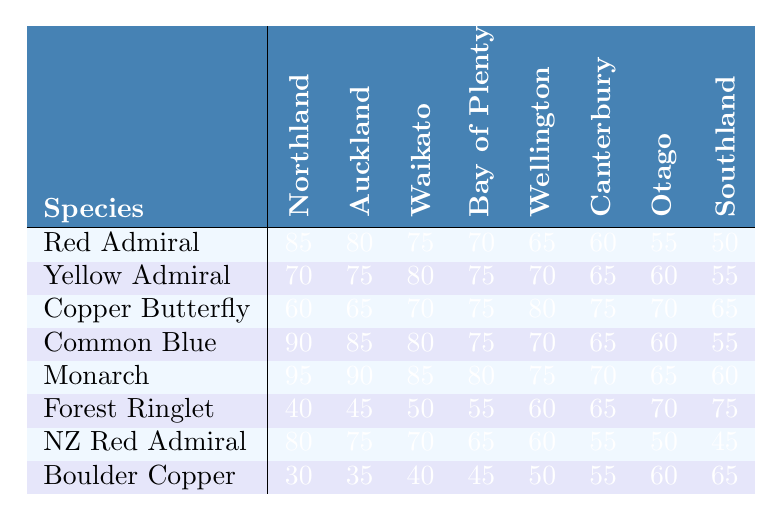What is the highest distribution value for the Monarch species? The table shows the distribution values for the Monarch species across the regions. The highest value listed is 95, corresponding to Northland.
Answer: 95 Which butterfly species has the lowest distribution in Southland? Looking at the Southland column, the lowest value is 45, which belongs to the New Zealand Red Admiral species.
Answer: New Zealand Red Admiral What is the average distribution for the Yellow Admiral species across all regions? To find the average for the Yellow Admiral, sum the distribution values (70 + 75 + 80 + 75 + 70 + 65 + 60 + 55) = 570, then divide by the number of regions (8): 570 / 8 = 71.25.
Answer: 71.25 Is the distribution of the Forest Ringlet species increasing or decreasing as one moves from Northland to Southland? Checking the distribution values for the Forest Ringlet from Northland to Southland (40, 45, 50, 55, 60, 65, 70, 75), we see that each subsequent value increases.
Answer: Increasing What is the difference in distribution between the Common Blue and Copper Butterfly in Wellington? The distribution for Common Blue in Wellington is 70 and for Copper Butterfly, it is 80. The difference is 80 - 70 = 10.
Answer: 10 Which species shows the most consistent distribution across all regions? The Copper Butterfly's distribution values (60, 65, 70, 75, 80, 75, 70, 65) vary by a maximum of 20 from the lowest to the highest, indicating a relatively stable pattern compared to others.
Answer: Copper Butterfly If we sum the distribution values for the Boulder Copper across all regions, what is the total? Adding up the Boulder Copper's distribution values (30 + 35 + 40 + 45 + 50 + 55 + 60 + 65) results in a total of 410.
Answer: 410 What is the median distribution value for the Red Admiral species across all regions? The distribution values for Red Admiral (50, 55, 60, 65, 70, 75, 80, 85) can be arranged in order. The median, being the average of the two middle values (70 and 75), is (70 + 75) / 2 = 72.5.
Answer: 72.5 Which species has a higher distribution in Otago: New Zealand Red Admiral or Forest Ringlet? The New Zealand Red Admiral has a distribution value of 50 in Otago, while the Forest Ringlet has a value of 70. Thus, the Forest Ringlet has a higher distribution.
Answer: Forest Ringlet What is the trend in distribution for the Copper Butterfly from Northland to Wellington? The distribution values for Copper Butterfly (60, 65, 70, 75, 80, 75) show an overall increasing trend until it peaks at 80 in Wellington and then decreases to 75 in Canterbury.
Answer: Increasing then decreasing 